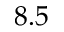<formula> <loc_0><loc_0><loc_500><loc_500>8 . 5</formula> 